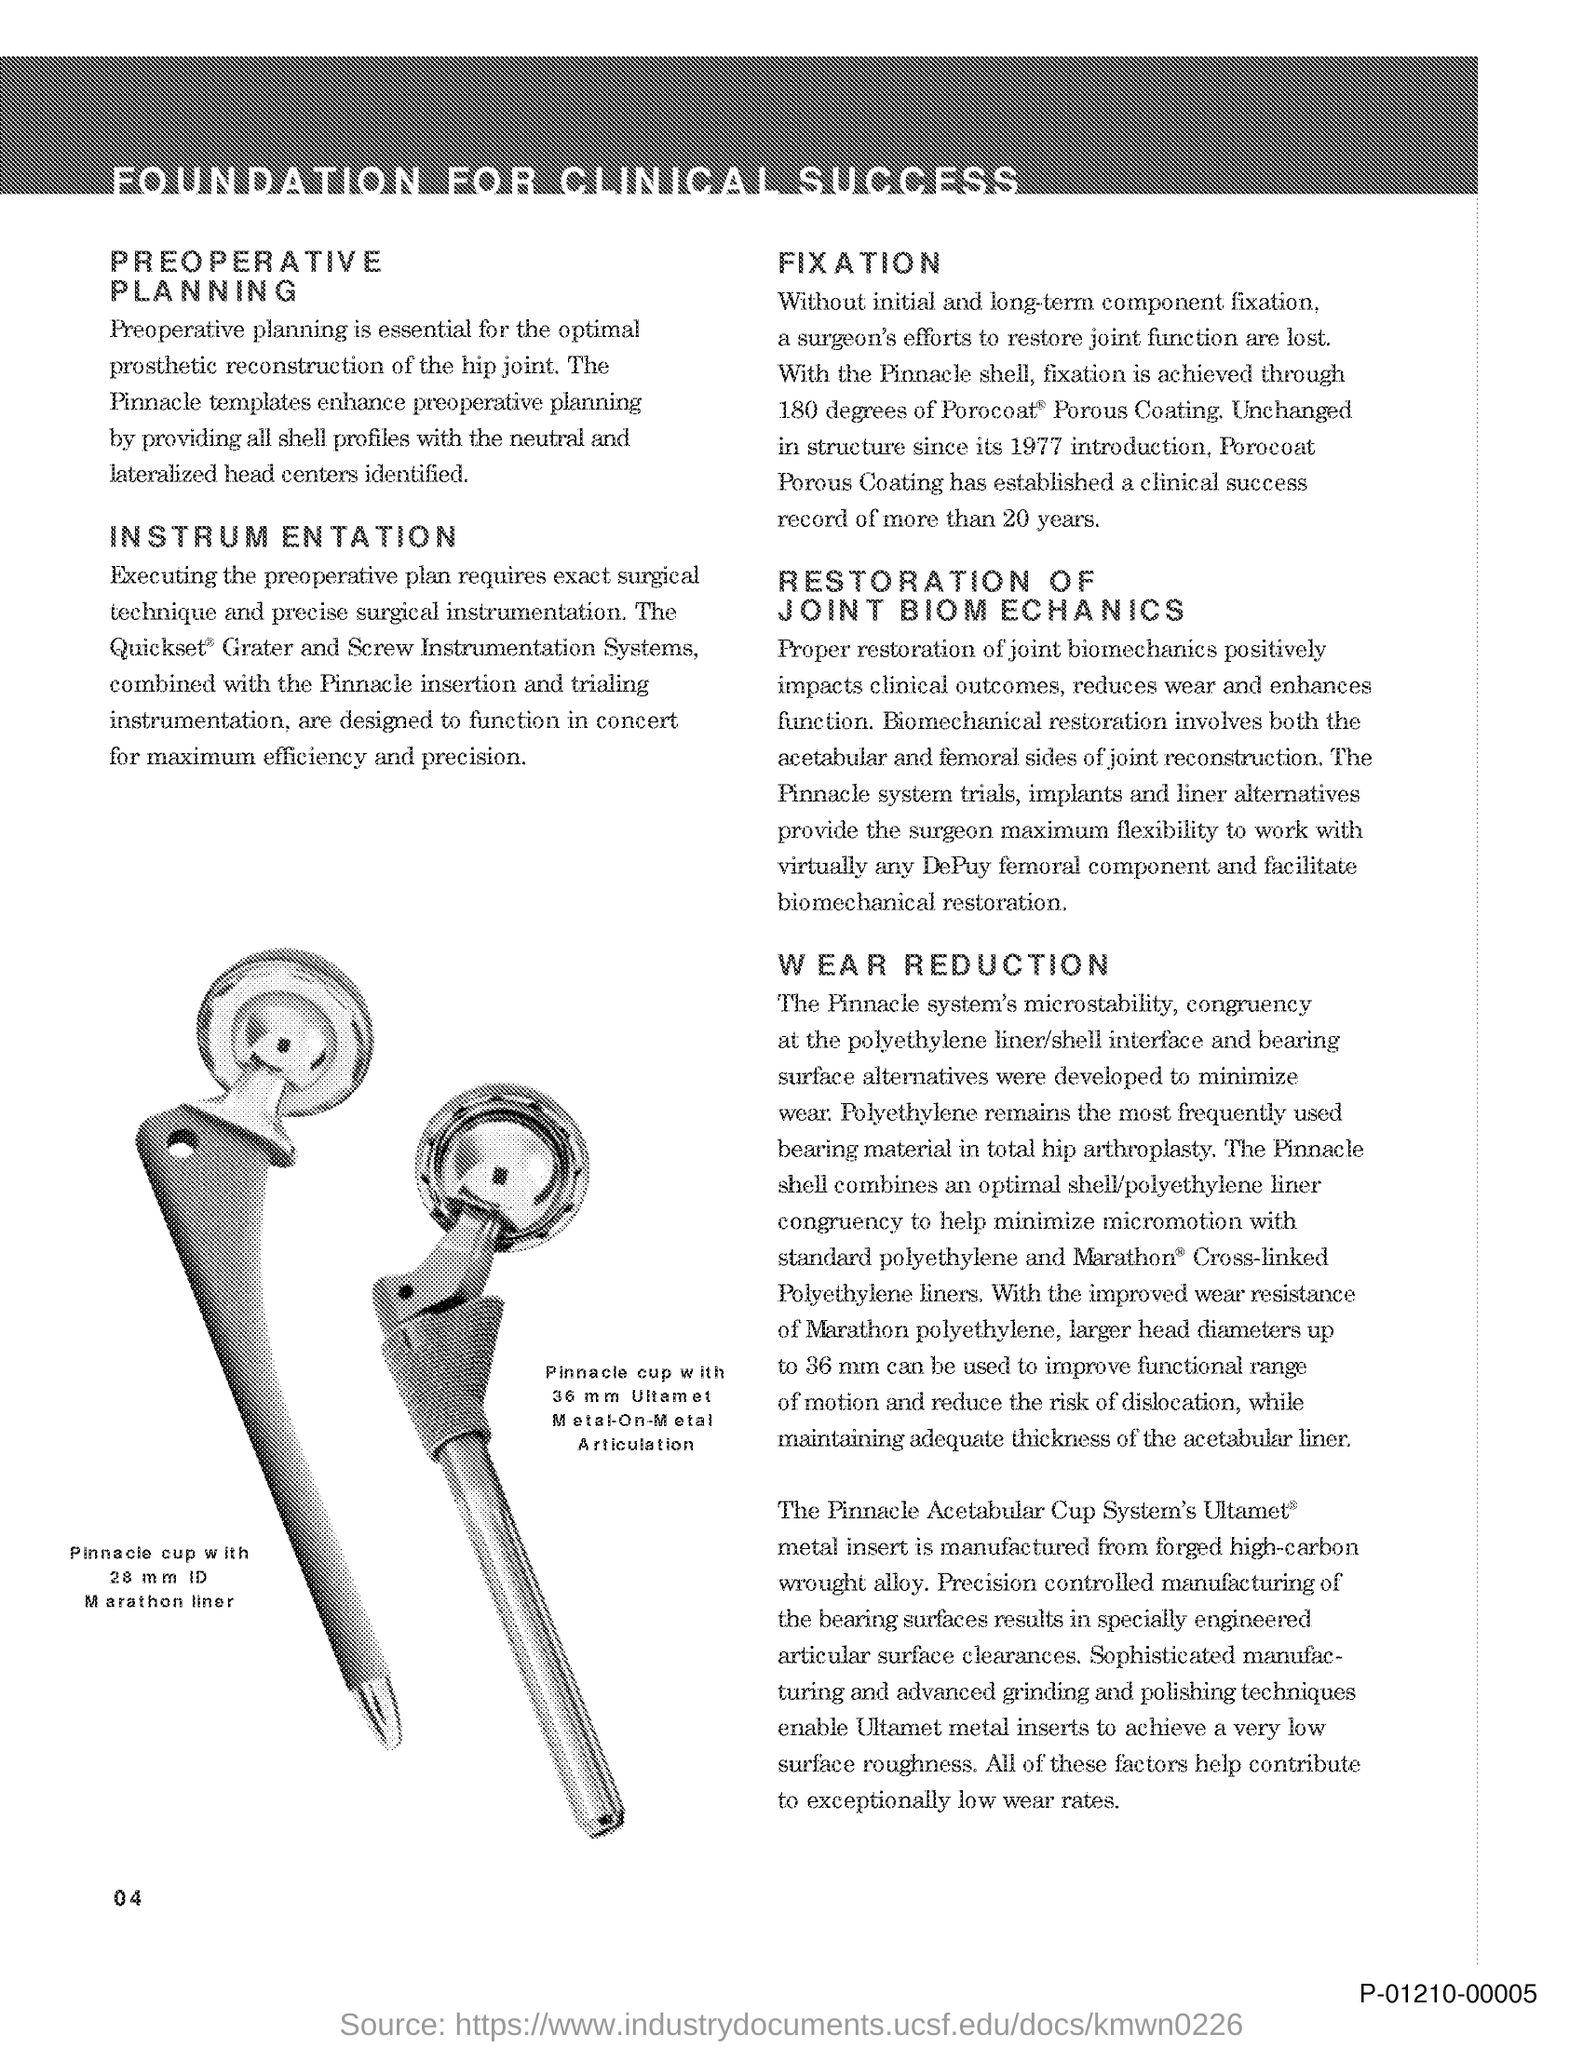What is the title of the document?
Ensure brevity in your answer.  Foundation for clinical success. What is the Page Number?
Your response must be concise. 04. 